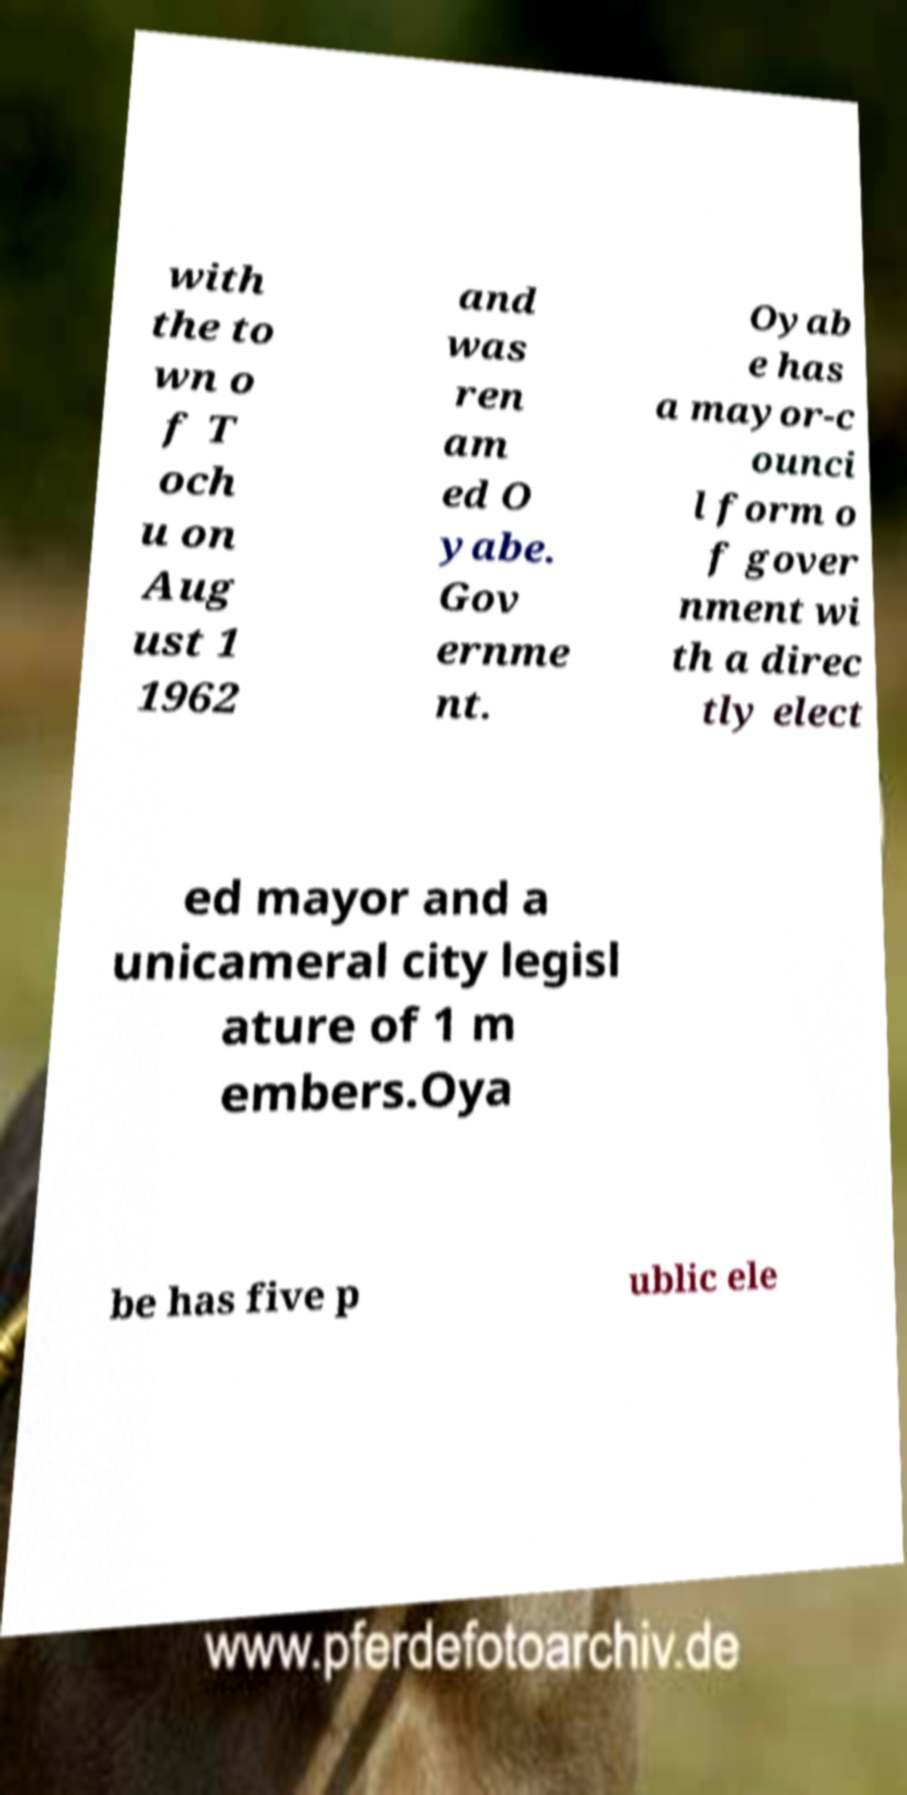Could you assist in decoding the text presented in this image and type it out clearly? with the to wn o f T och u on Aug ust 1 1962 and was ren am ed O yabe. Gov ernme nt. Oyab e has a mayor-c ounci l form o f gover nment wi th a direc tly elect ed mayor and a unicameral city legisl ature of 1 m embers.Oya be has five p ublic ele 